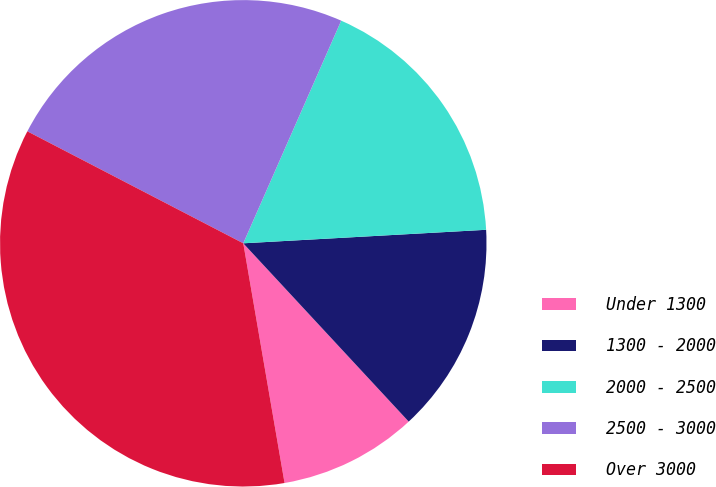<chart> <loc_0><loc_0><loc_500><loc_500><pie_chart><fcel>Under 1300<fcel>1300 - 2000<fcel>2000 - 2500<fcel>2500 - 3000<fcel>Over 3000<nl><fcel>9.19%<fcel>13.98%<fcel>17.52%<fcel>23.98%<fcel>35.33%<nl></chart> 